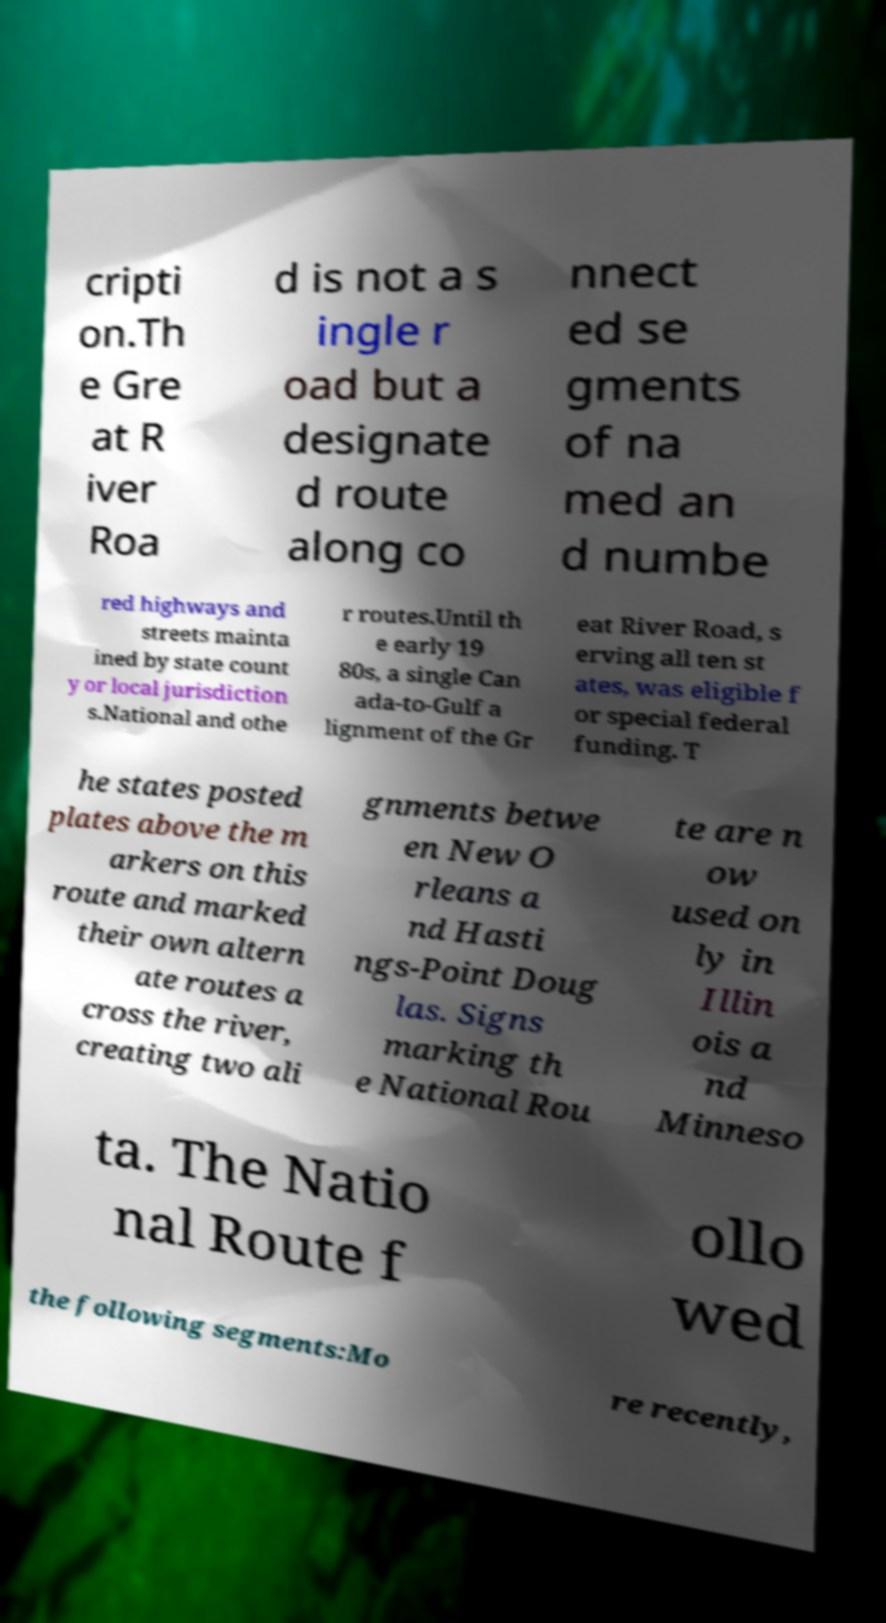There's text embedded in this image that I need extracted. Can you transcribe it verbatim? cripti on.Th e Gre at R iver Roa d is not a s ingle r oad but a designate d route along co nnect ed se gments of na med an d numbe red highways and streets mainta ined by state count y or local jurisdiction s.National and othe r routes.Until th e early 19 80s, a single Can ada-to-Gulf a lignment of the Gr eat River Road, s erving all ten st ates, was eligible f or special federal funding. T he states posted plates above the m arkers on this route and marked their own altern ate routes a cross the river, creating two ali gnments betwe en New O rleans a nd Hasti ngs-Point Doug las. Signs marking th e National Rou te are n ow used on ly in Illin ois a nd Minneso ta. The Natio nal Route f ollo wed the following segments:Mo re recently, 